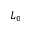Convert formula to latex. <formula><loc_0><loc_0><loc_500><loc_500>L _ { 0 }</formula> 